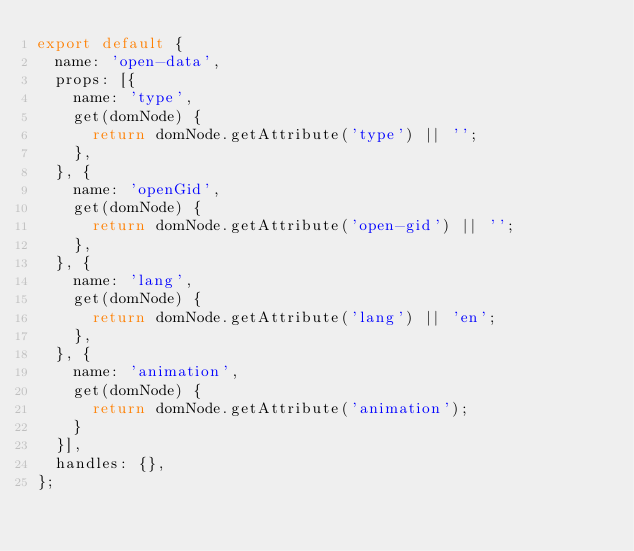<code> <loc_0><loc_0><loc_500><loc_500><_JavaScript_>export default {
  name: 'open-data',
  props: [{
    name: 'type',
    get(domNode) {
      return domNode.getAttribute('type') || '';
    },
  }, {
    name: 'openGid',
    get(domNode) {
      return domNode.getAttribute('open-gid') || '';
    },
  }, {
    name: 'lang',
    get(domNode) {
      return domNode.getAttribute('lang') || 'en';
    },
  }, {
    name: 'animation',
    get(domNode) {
      return domNode.getAttribute('animation');
    }
  }],
  handles: {},
};
</code> 